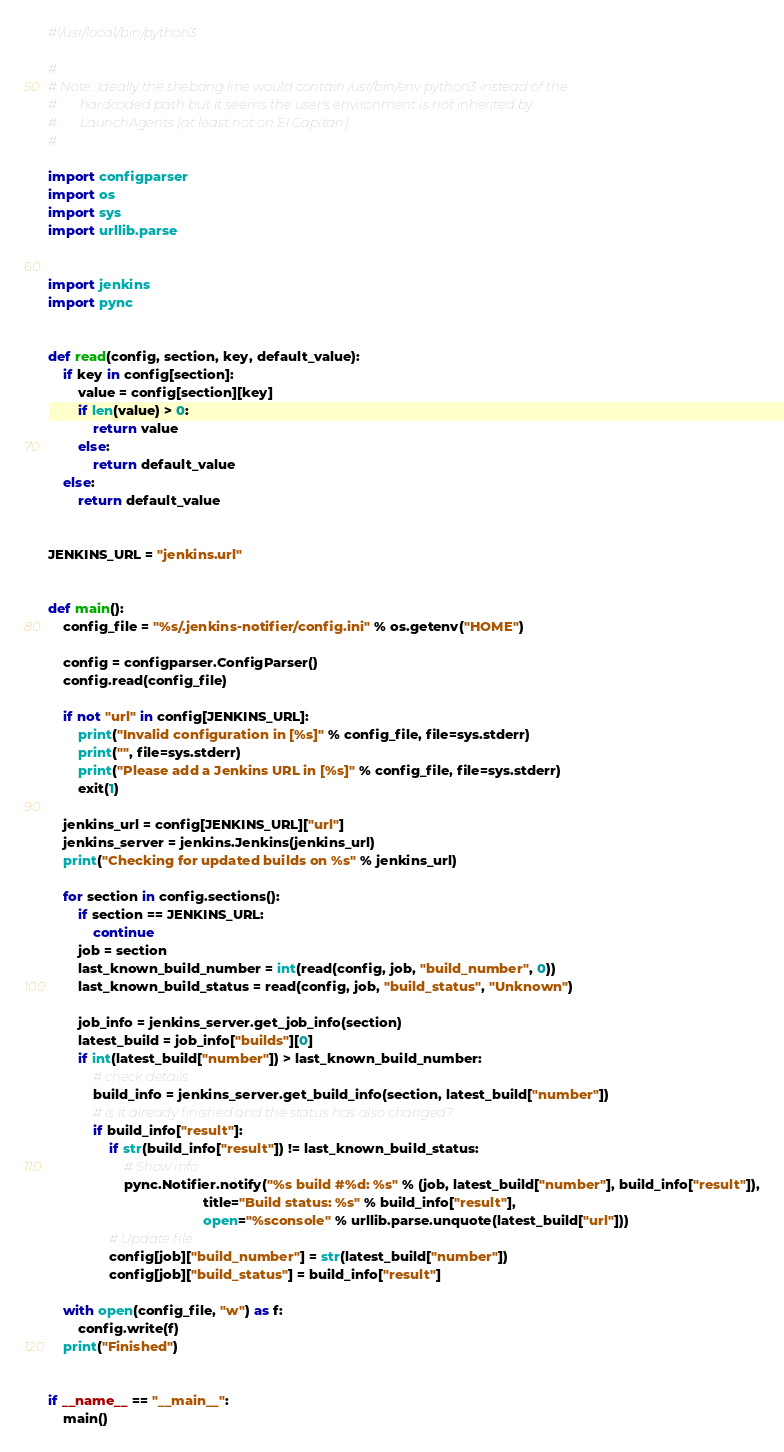<code> <loc_0><loc_0><loc_500><loc_500><_Python_>#!/usr/local/bin/python3

#
# Note: Ideally the shebang line would contain /usr/bin/env python3 instead of the
#       hardcoded path but it seems the user's environment is not inherited by
#       LaunchAgents (at least not on El Capitan).
#

import configparser
import os
import sys
import urllib.parse


import jenkins
import pync


def read(config, section, key, default_value):
    if key in config[section]:
        value = config[section][key]
        if len(value) > 0:
            return value
        else:
            return default_value
    else:
        return default_value


JENKINS_URL = "jenkins.url"


def main():
    config_file = "%s/.jenkins-notifier/config.ini" % os.getenv("HOME")

    config = configparser.ConfigParser()
    config.read(config_file)

    if not "url" in config[JENKINS_URL]:
        print("Invalid configuration in [%s]" % config_file, file=sys.stderr)
        print("", file=sys.stderr)
        print("Please add a Jenkins URL in [%s]" % config_file, file=sys.stderr)
        exit(1)

    jenkins_url = config[JENKINS_URL]["url"]
    jenkins_server = jenkins.Jenkins(jenkins_url)
    print("Checking for updated builds on %s" % jenkins_url)

    for section in config.sections():
        if section == JENKINS_URL:
            continue
        job = section
        last_known_build_number = int(read(config, job, "build_number", 0))
        last_known_build_status = read(config, job, "build_status", "Unknown")

        job_info = jenkins_server.get_job_info(section)
        latest_build = job_info["builds"][0]
        if int(latest_build["number"]) > last_known_build_number:
            # check details
            build_info = jenkins_server.get_build_info(section, latest_build["number"])
            # is it already finished and the status has also changed?
            if build_info["result"]:
                if str(build_info["result"]) != last_known_build_status:
                    # Show info
                    pync.Notifier.notify("%s build #%d: %s" % (job, latest_build["number"], build_info["result"]),
                                         title="Build status: %s" % build_info["result"],
                                         open="%sconsole" % urllib.parse.unquote(latest_build["url"]))
                # Update file
                config[job]["build_number"] = str(latest_build["number"])
                config[job]["build_status"] = build_info["result"]

    with open(config_file, "w") as f:
        config.write(f)
    print("Finished")


if __name__ == "__main__":
    main()
</code> 